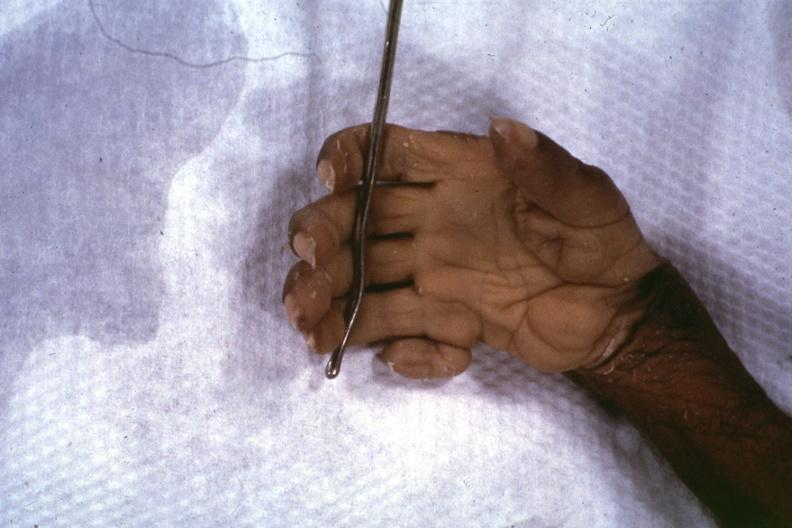does endocrine show close-up supernumerary digit?
Answer the question using a single word or phrase. Yes 